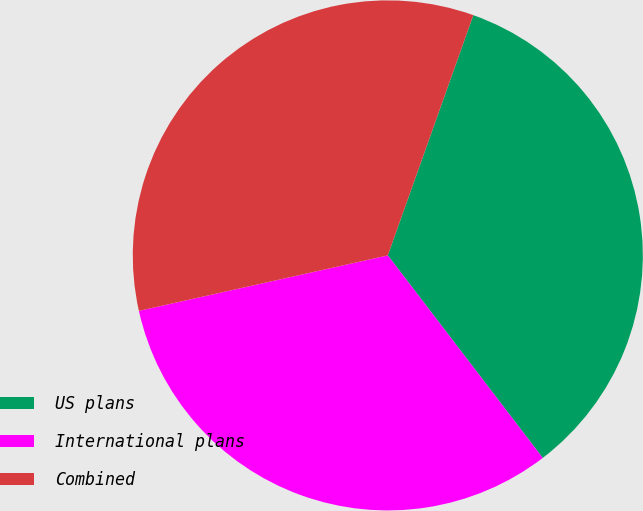Convert chart. <chart><loc_0><loc_0><loc_500><loc_500><pie_chart><fcel>US plans<fcel>International plans<fcel>Combined<nl><fcel>34.16%<fcel>31.9%<fcel>33.93%<nl></chart> 